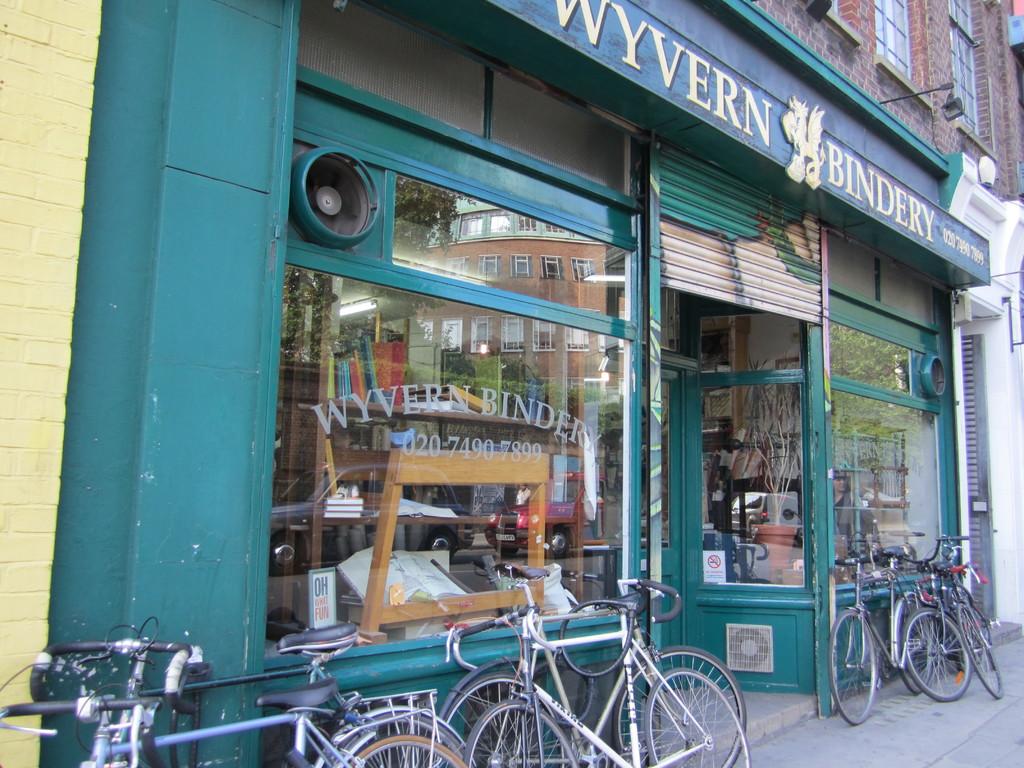What is the number listed for this business?
Provide a succinct answer. 020 7490 7899. What kind of business is this?
Provide a short and direct response. Bindery. 